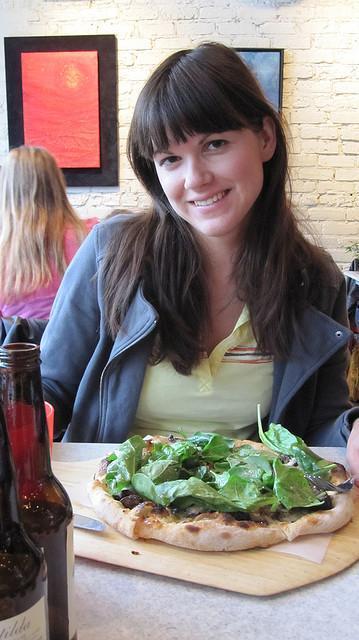How many pizzas are there?
Give a very brief answer. 1. How many bottles are there?
Give a very brief answer. 2. How many people are in the photo?
Give a very brief answer. 2. 